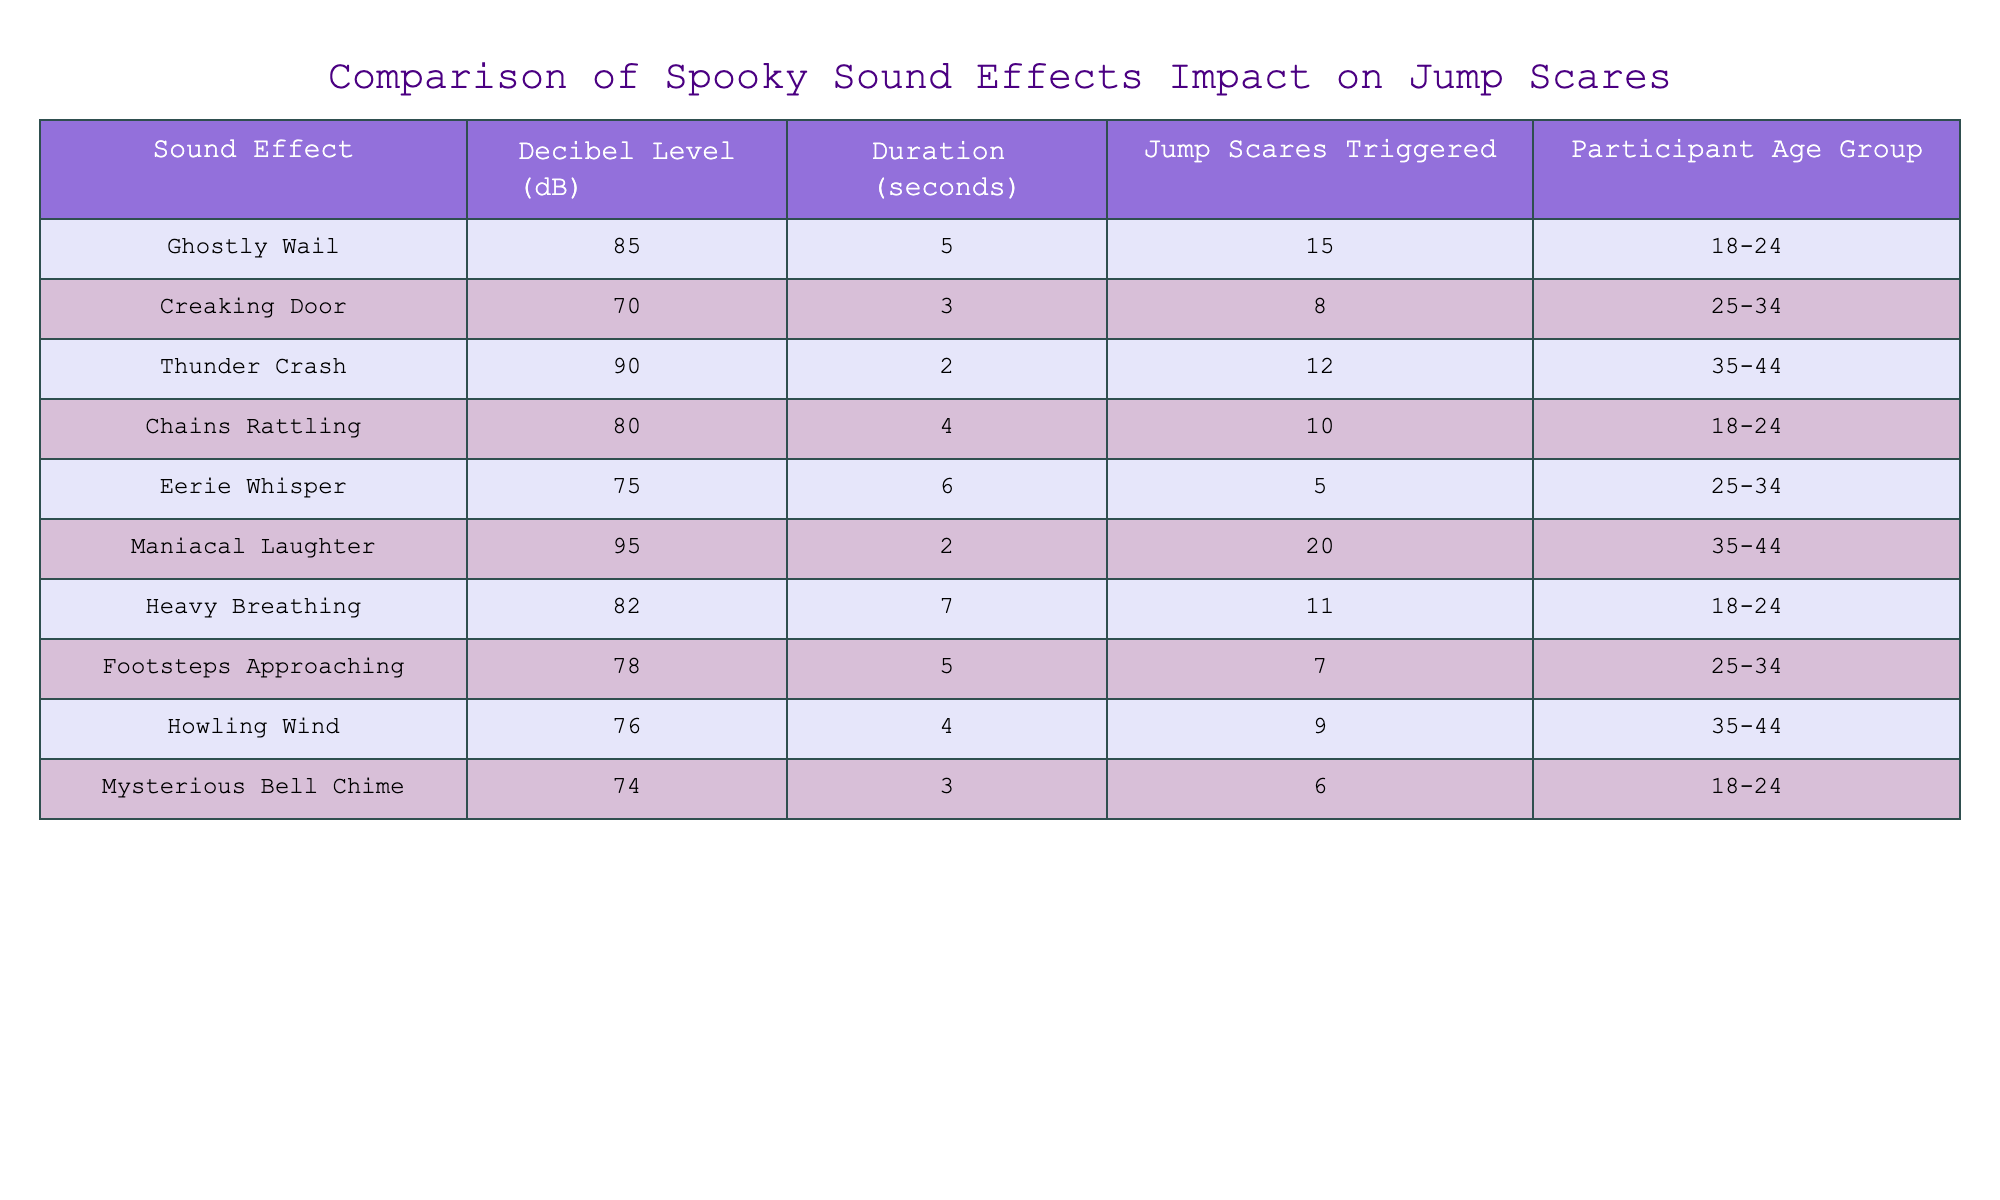What is the jump scare count triggered by the Ghostly Wail sound effect? The Ghostly Wail, listed in the table, shows that it triggered 15 jump scares. This information is directly available in the 'Jump Scares Triggered' column for the 'Ghostly Wail' row.
Answer: 15 Which sound effect has the highest decibel level? By examining the 'Decibel Level (dB)' column, the Maniacal Laughter sound effect registers at 95 dB, which is the highest compared to the other sound effects listed in the table.
Answer: 95 What is the average duration of sound effects that triggered more than 10 jump scares? The sound effects that triggered more than 10 jump scares are Ghostly Wail (5 seconds), Thunder Crash (2 seconds), and Maniacal Laughter (2 seconds). Adding these durations gives 5 + 2 + 2 = 9 seconds. Dividing by the number of sound effects (3) gives an average of 9/3 = 3 seconds.
Answer: 3 Does the Creaking Door sound effect trigger more jump scares than Eerie Whisper? The Creaking Door triggered 8 jump scares while the Eerie Whisper triggered only 5. Since 8 is greater than 5, the statement is true.
Answer: Yes Which age group experienced the highest number of jump scares in total? To find the jump scare totals for each age group, we sum jump scares: 18-24 (15 + 10 + 11 + 6 = 42), 25-34 (8 + 5 + 7 = 20), 35-44 (12 + 20 + 9 = 41). The highest total is for the group 18-24 with 42 jump scares.
Answer: 18-24 How many sound effects have a duration greater than 5 seconds? Reviewing the 'Duration (seconds)' column, only the Heavy Breathing (7 seconds) and Eerie Whisper (6 seconds) effects have durations greater than 5 seconds. Thus, there are only 2 sound effects in total.
Answer: 2 What is the total number of jump scares triggered by sound effects with a decibel level above 80 dB? The sound effects above 80 dB are Ghostly Wail (15), Thunder Crash (12), Maniacal Laughter (20), and Heavy Breathing (11). Adding these yields 15 + 12 + 20 + 11 = 58 total jump scares.
Answer: 58 Which sound effect had the lowest number of jump scares triggered? Observing the 'Jump Scares Triggered' column, the Eerie Whisper had the lowest count of jump scares, with a total of 5. This can be validated by comparing all values in that column.
Answer: 5 